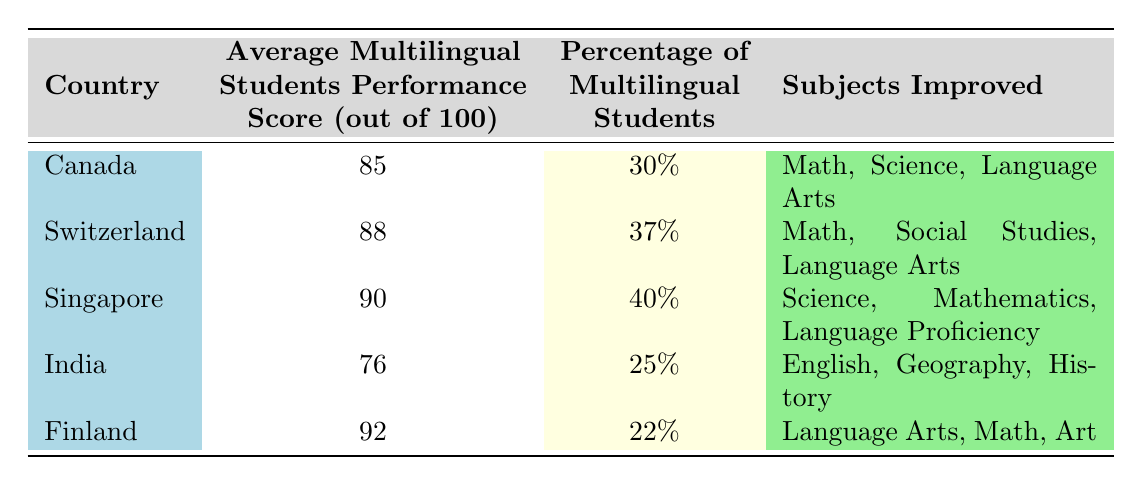What is the average multilingual students performance score in Canada? The table shows that the average multilingual students performance score in Canada is 85.
Answer: 85 Which country has the highest percentage of multilingual students? By comparing the percentages of multilingual students in each country, Singapore has the highest at 40%.
Answer: 40% Did India score above 80 in the average multilingual students performance score? The average score for India is 76, which is below 80.
Answer: No What are the subjects that improved for students in Switzerland? For Switzerland, the subjects that improved are Math, Social Studies, and Language Arts, as listed in the table.
Answer: Math, Social Studies, Language Arts Calculate the difference in the average multilingual students performance score between Finland and India. Finland's score is 92 and India's score is 76. The difference is 92 - 76 = 16.
Answer: 16 Is the average multilingual students performance score higher in Canada than in Finland? The average score for Canada is 85, while Finland's score is 92. Since 85 is less than 92, the statement is false.
Answer: No What is the combined percentage of multilingual students in Canada and India? The percentage of multilingual students in Canada is 30%, and in India, it’s 25%. Adding these gives 30 + 25 = 55.
Answer: 55 Which subjects improved for Singapore? The subjects that improved for Singapore include Science, Mathematics, and Language Proficiency, as shown in the table.
Answer: Science, Mathematics, Language Proficiency How many countries have an average performance score of 85 or above? Looking at the scores in the table, Canada (85), Switzerland (88), Singapore (90), and Finland (92) all have scores of 85 or above. There are 4 such countries.
Answer: 4 